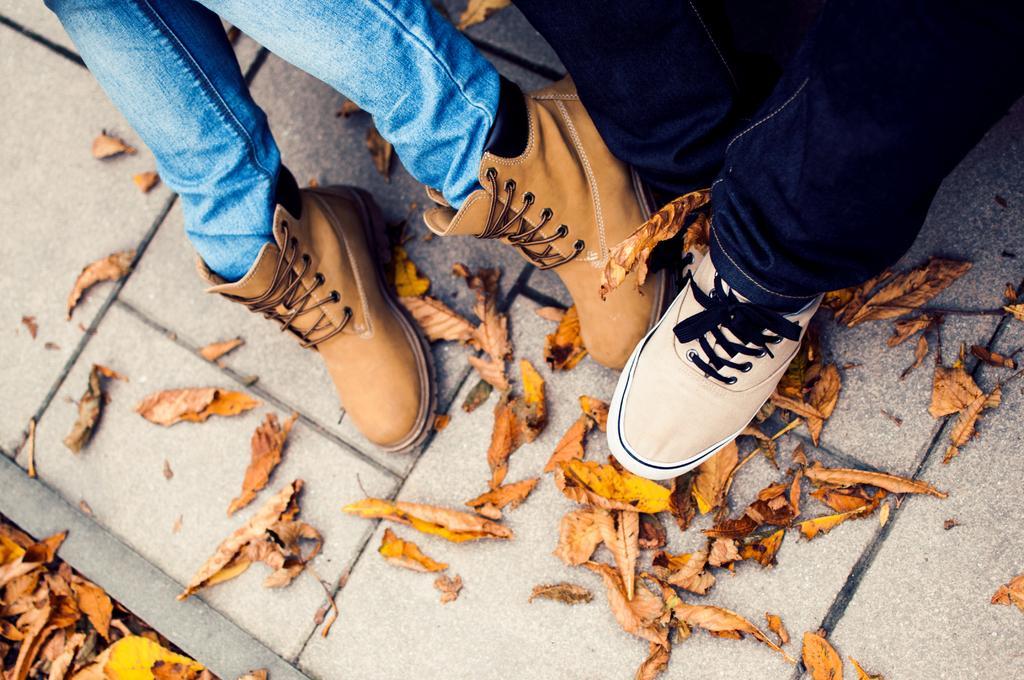In one or two sentences, can you explain what this image depicts? There are legs of persons with shoes. On the ground there is brick floor. Also there are dried leaves on the ground. 